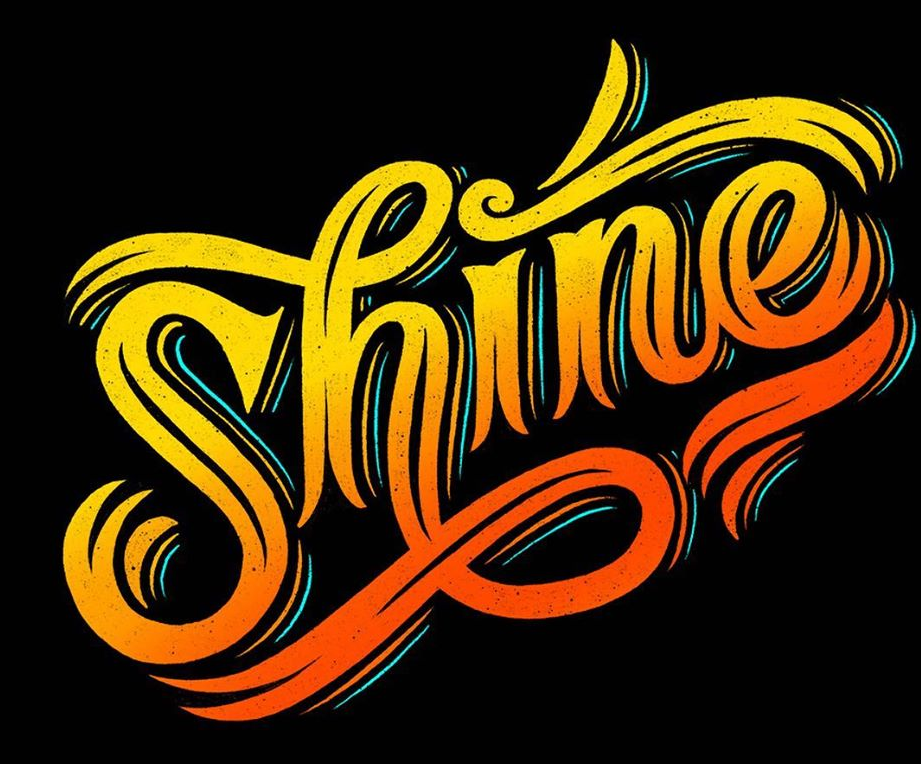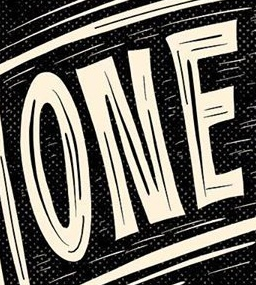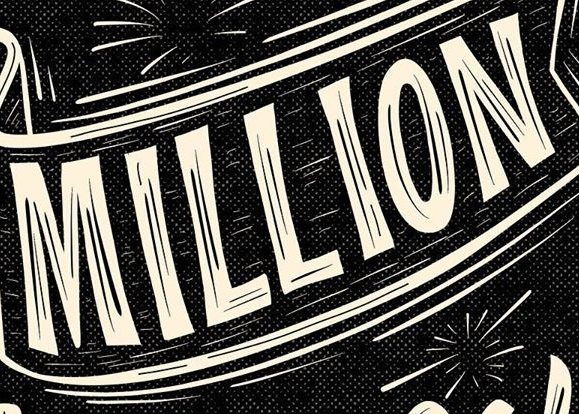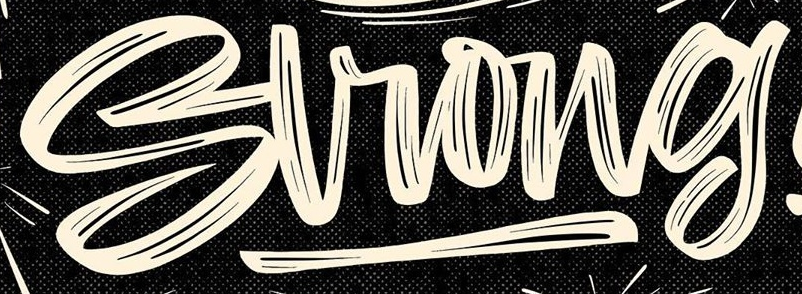What text appears in these images from left to right, separated by a semicolon? Shine; ONE; MILLION; Strong 